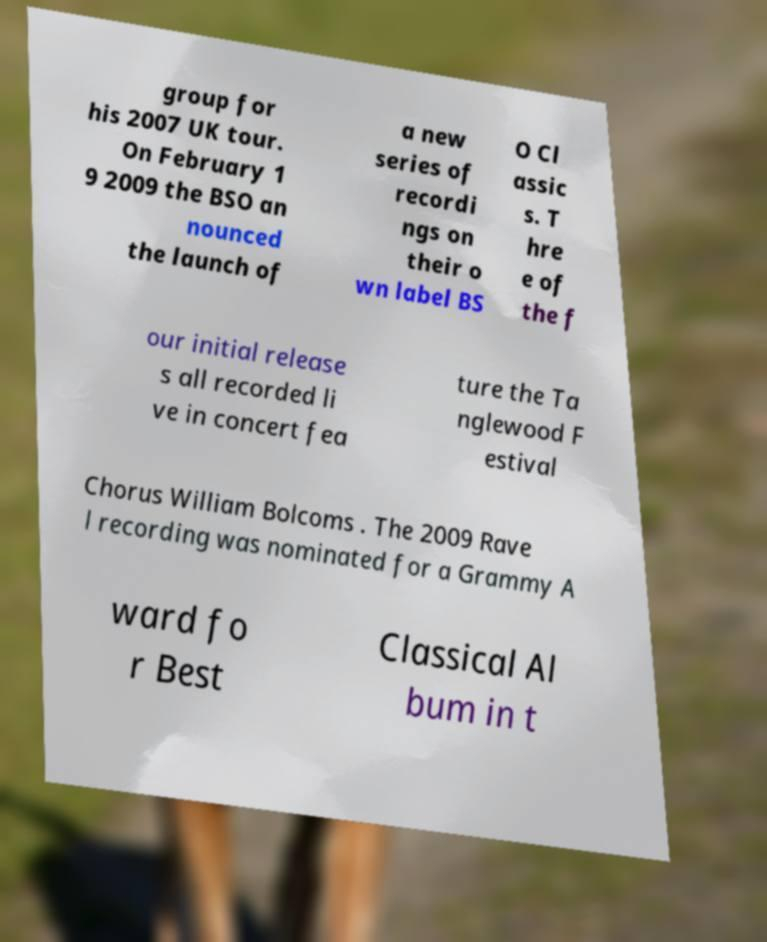Could you extract and type out the text from this image? group for his 2007 UK tour. On February 1 9 2009 the BSO an nounced the launch of a new series of recordi ngs on their o wn label BS O Cl assic s. T hre e of the f our initial release s all recorded li ve in concert fea ture the Ta nglewood F estival Chorus William Bolcoms . The 2009 Rave l recording was nominated for a Grammy A ward fo r Best Classical Al bum in t 